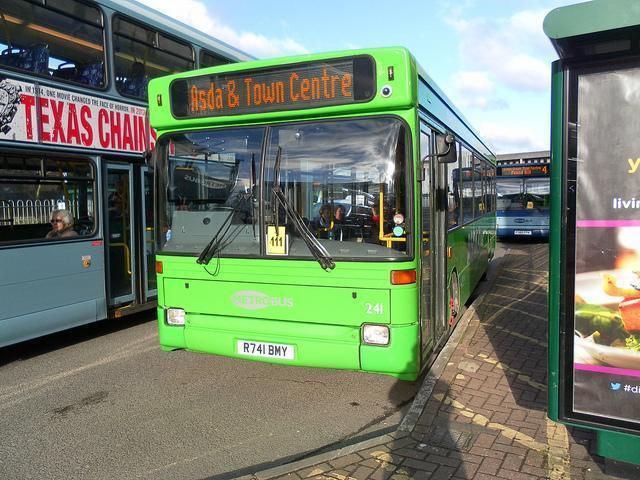How many buses are in the picture?
Give a very brief answer. 2. How many sinks are there?
Give a very brief answer. 0. 